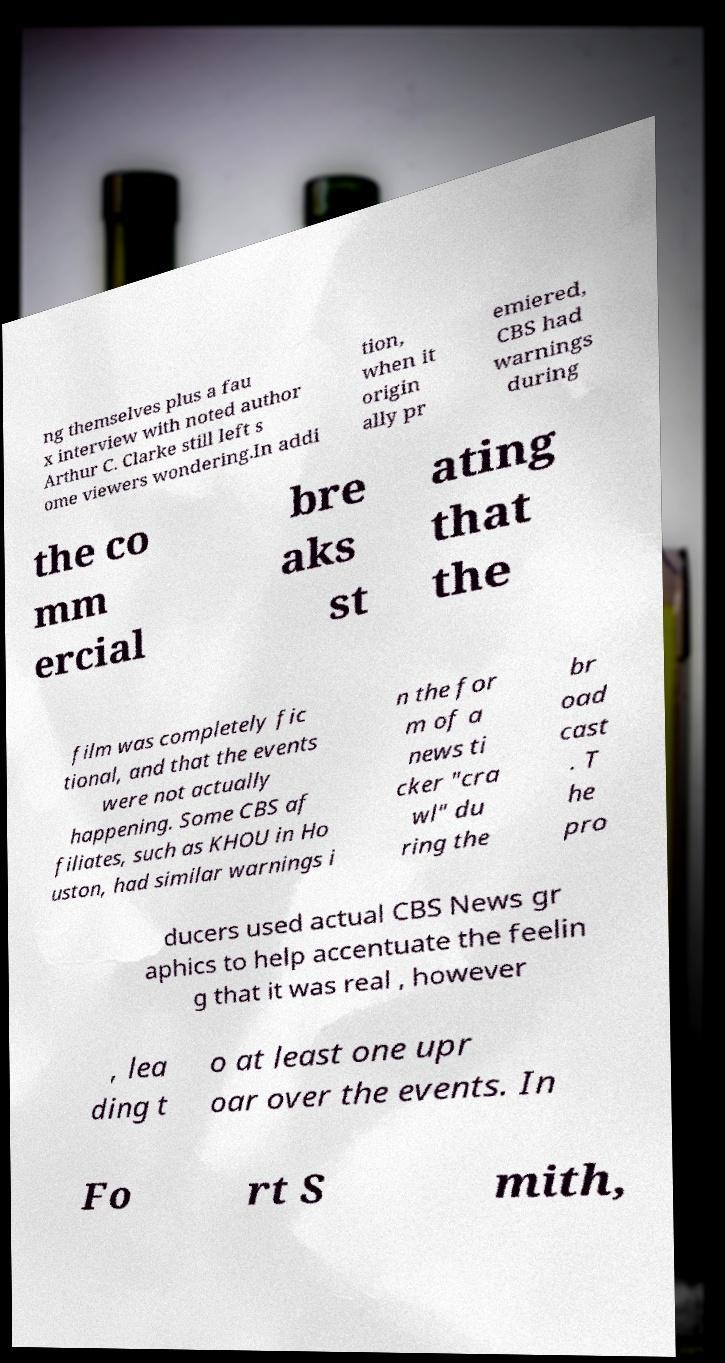Can you accurately transcribe the text from the provided image for me? ng themselves plus a fau x interview with noted author Arthur C. Clarke still left s ome viewers wondering.In addi tion, when it origin ally pr emiered, CBS had warnings during the co mm ercial bre aks st ating that the film was completely fic tional, and that the events were not actually happening. Some CBS af filiates, such as KHOU in Ho uston, had similar warnings i n the for m of a news ti cker "cra wl" du ring the br oad cast . T he pro ducers used actual CBS News gr aphics to help accentuate the feelin g that it was real , however , lea ding t o at least one upr oar over the events. In Fo rt S mith, 